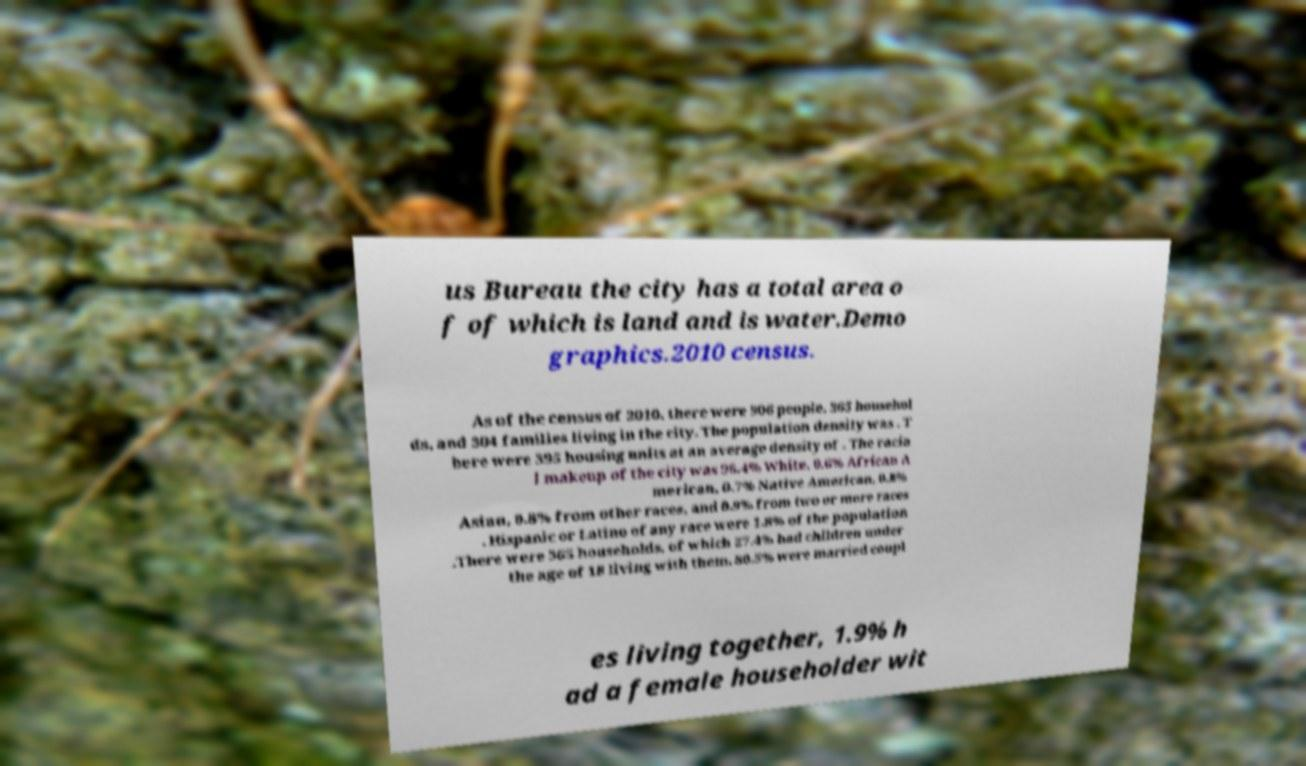There's text embedded in this image that I need extracted. Can you transcribe it verbatim? us Bureau the city has a total area o f of which is land and is water.Demo graphics.2010 census. As of the census of 2010, there were 906 people, 365 househol ds, and 304 families living in the city. The population density was . T here were 395 housing units at an average density of . The racia l makeup of the city was 96.4% White, 0.6% African A merican, 0.7% Native American, 0.8% Asian, 0.8% from other races, and 0.9% from two or more races . Hispanic or Latino of any race were 1.8% of the population .There were 365 households, of which 27.4% had children under the age of 18 living with them, 80.5% were married coupl es living together, 1.9% h ad a female householder wit 